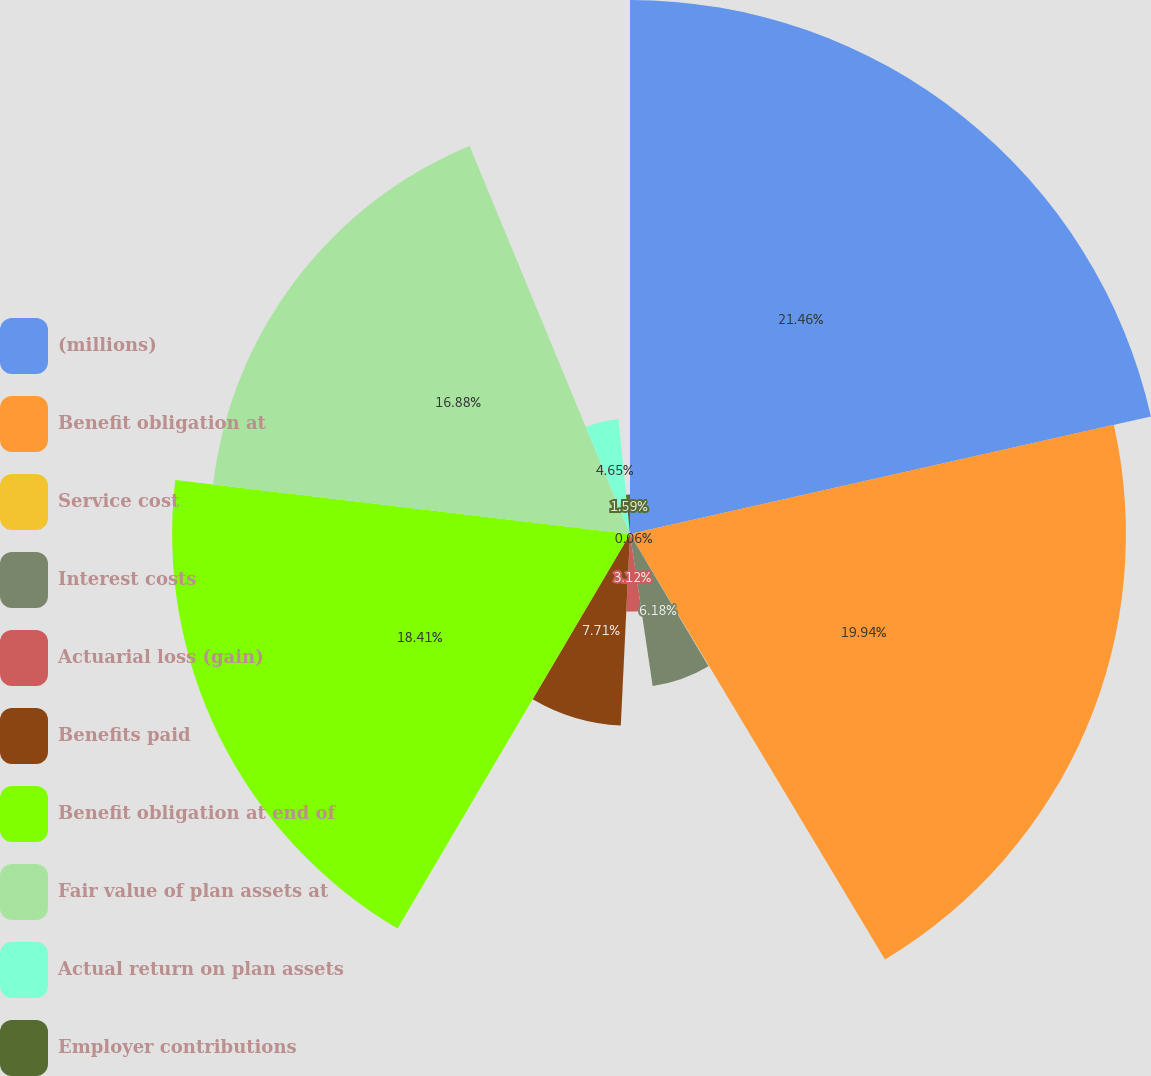<chart> <loc_0><loc_0><loc_500><loc_500><pie_chart><fcel>(millions)<fcel>Benefit obligation at<fcel>Service cost<fcel>Interest costs<fcel>Actuarial loss (gain)<fcel>Benefits paid<fcel>Benefit obligation at end of<fcel>Fair value of plan assets at<fcel>Actual return on plan assets<fcel>Employer contributions<nl><fcel>21.47%<fcel>19.94%<fcel>0.06%<fcel>6.18%<fcel>3.12%<fcel>7.71%<fcel>18.41%<fcel>16.88%<fcel>4.65%<fcel>1.59%<nl></chart> 